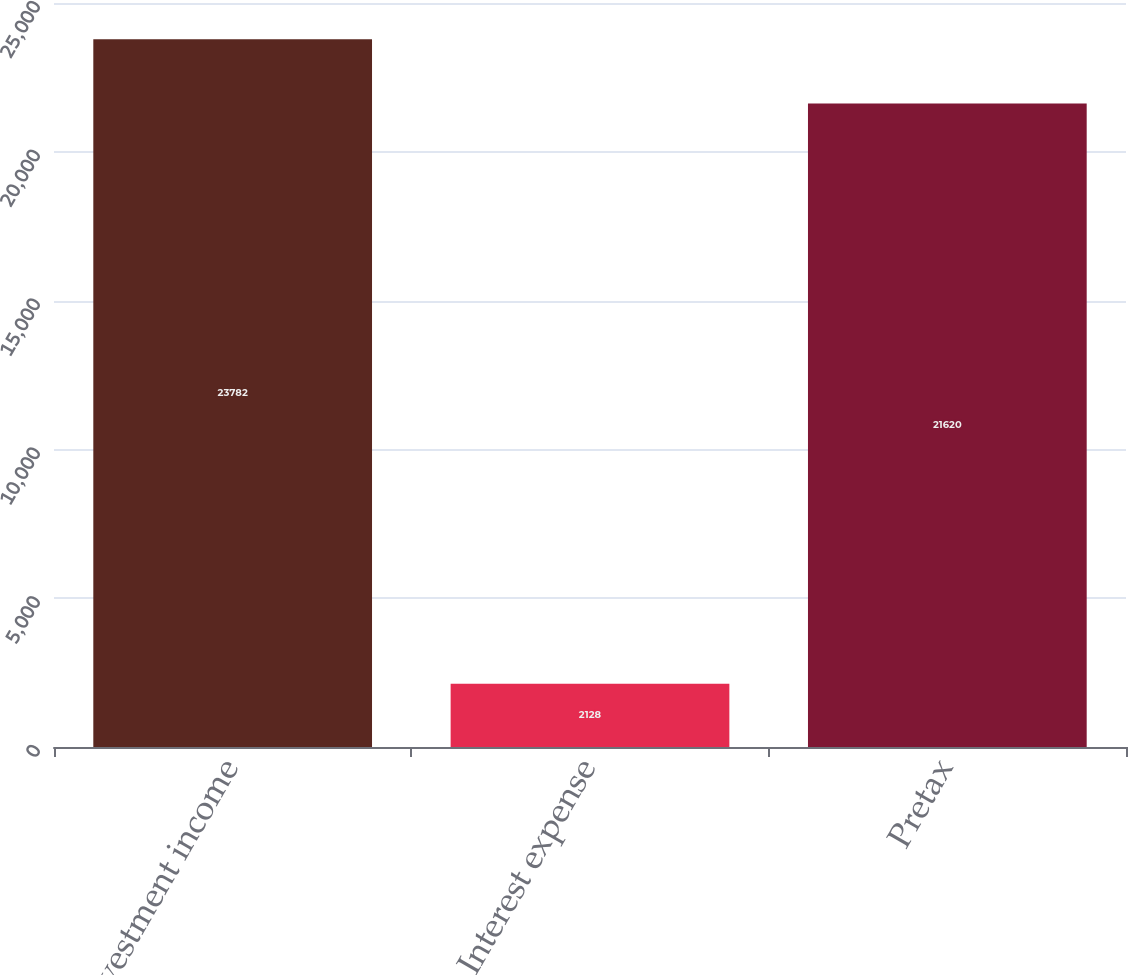<chart> <loc_0><loc_0><loc_500><loc_500><bar_chart><fcel>Investment income<fcel>Interest expense<fcel>Pretax<nl><fcel>23782<fcel>2128<fcel>21620<nl></chart> 